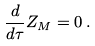<formula> <loc_0><loc_0><loc_500><loc_500>\frac { d } { d \tau } Z _ { M } = 0 \, .</formula> 